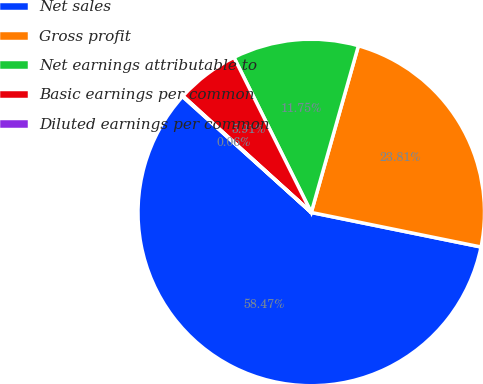<chart> <loc_0><loc_0><loc_500><loc_500><pie_chart><fcel>Net sales<fcel>Gross profit<fcel>Net earnings attributable to<fcel>Basic earnings per common<fcel>Diluted earnings per common<nl><fcel>58.48%<fcel>23.81%<fcel>11.75%<fcel>5.91%<fcel>0.06%<nl></chart> 